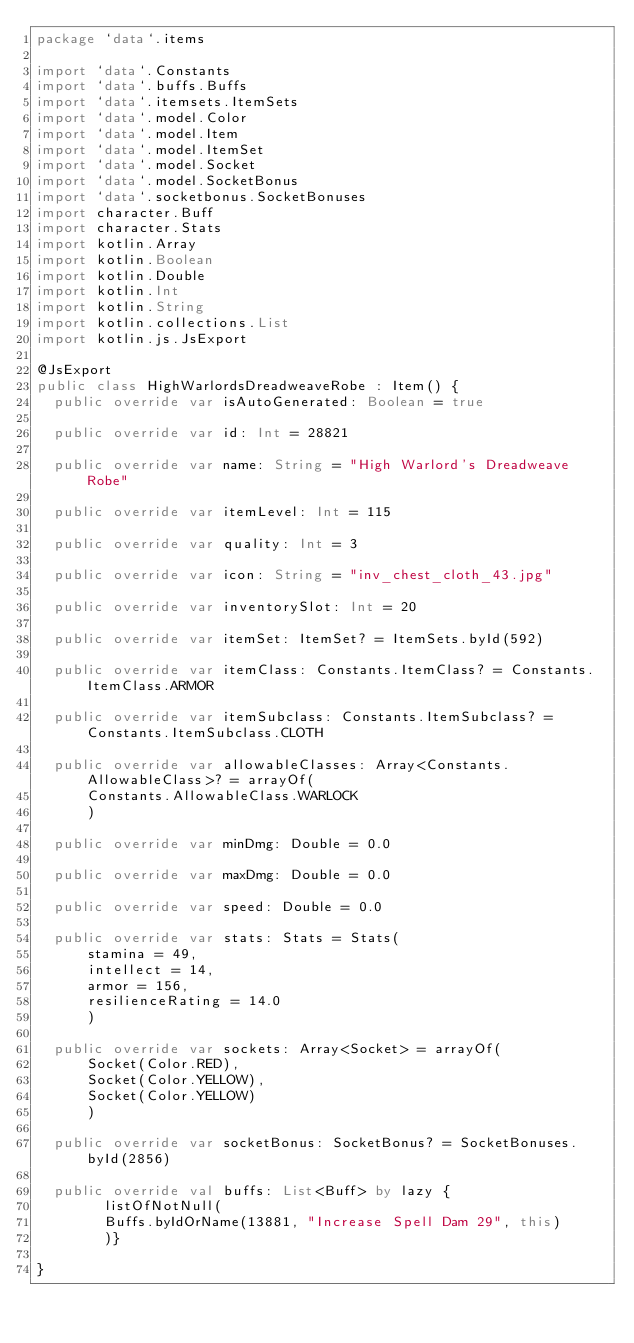Convert code to text. <code><loc_0><loc_0><loc_500><loc_500><_Kotlin_>package `data`.items

import `data`.Constants
import `data`.buffs.Buffs
import `data`.itemsets.ItemSets
import `data`.model.Color
import `data`.model.Item
import `data`.model.ItemSet
import `data`.model.Socket
import `data`.model.SocketBonus
import `data`.socketbonus.SocketBonuses
import character.Buff
import character.Stats
import kotlin.Array
import kotlin.Boolean
import kotlin.Double
import kotlin.Int
import kotlin.String
import kotlin.collections.List
import kotlin.js.JsExport

@JsExport
public class HighWarlordsDreadweaveRobe : Item() {
  public override var isAutoGenerated: Boolean = true

  public override var id: Int = 28821

  public override var name: String = "High Warlord's Dreadweave Robe"

  public override var itemLevel: Int = 115

  public override var quality: Int = 3

  public override var icon: String = "inv_chest_cloth_43.jpg"

  public override var inventorySlot: Int = 20

  public override var itemSet: ItemSet? = ItemSets.byId(592)

  public override var itemClass: Constants.ItemClass? = Constants.ItemClass.ARMOR

  public override var itemSubclass: Constants.ItemSubclass? = Constants.ItemSubclass.CLOTH

  public override var allowableClasses: Array<Constants.AllowableClass>? = arrayOf(
      Constants.AllowableClass.WARLOCK
      )

  public override var minDmg: Double = 0.0

  public override var maxDmg: Double = 0.0

  public override var speed: Double = 0.0

  public override var stats: Stats = Stats(
      stamina = 49,
      intellect = 14,
      armor = 156,
      resilienceRating = 14.0
      )

  public override var sockets: Array<Socket> = arrayOf(
      Socket(Color.RED),
      Socket(Color.YELLOW),
      Socket(Color.YELLOW)
      )

  public override var socketBonus: SocketBonus? = SocketBonuses.byId(2856)

  public override val buffs: List<Buff> by lazy {
        listOfNotNull(
        Buffs.byIdOrName(13881, "Increase Spell Dam 29", this)
        )}

}
</code> 